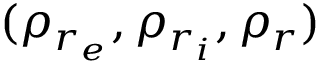<formula> <loc_0><loc_0><loc_500><loc_500>( \rho _ { r _ { e } } , \rho _ { r _ { i } } , \rho _ { r } )</formula> 